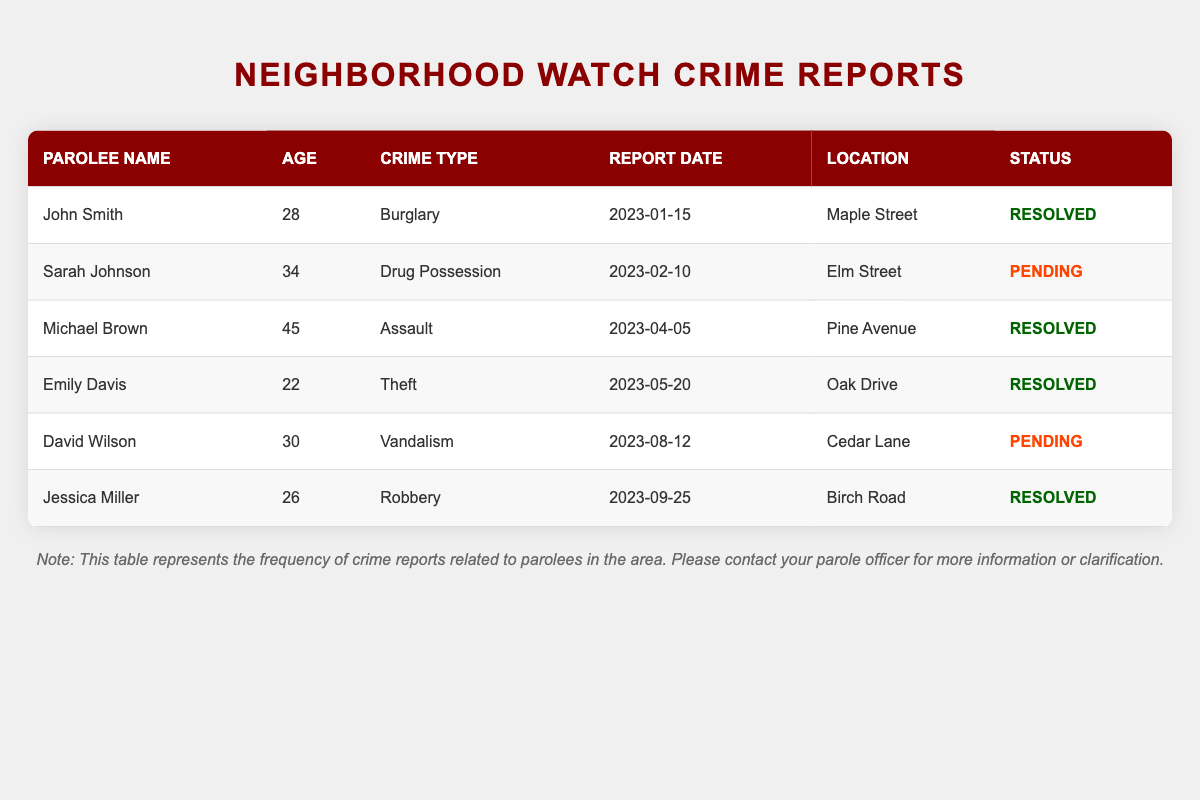What crime type was reported by Emily Davis? Emily Davis is listed in the table under the parolee name column, and her crime type is noted as Theft in the corresponding row.
Answer: Theft How many crime reports have a status of Pending? By reviewing the status column in the table, there are two entries with "Pending" status: one for Sarah Johnson and one for David Wilson.
Answer: 2 What is the average age of the parolees in the table? The ages of the parolees are 28, 34, 45, 22, 30, and 26. To find the average, sum these ages: 28 + 34 + 45 + 22 + 30 + 26 = 185. There are 6 parolees, so divide the total by 6: 185 / 6 = approximately 30.83.
Answer: 30.83 Is it true that no crime reports have been resolved for drug possession? In the table, Sarah Johnson's crime report for Drug Possession has a status of Pending, and there are no entries showing it as resolved. Therefore, it is true that no crime reports for this type have been resolved.
Answer: Yes Which location had the highest crime report in the table? To determine the highest crime report location, observe the report location column. Each location is listed only once. Thus, each location's crime count is equal, making it not applicable to define a single 'highest' location.
Answer: Not applicable How many resolved crime reports were made by individuals aged 30 or older? From the table, we look at the resolved crime reports: John Smith (28), Michael Brown (45), Emily Davis (22), and Jessica Miller (26). Only Michael Brown (age 45) falls into the 30 or older category and is marked as resolved. Hence, the answer is one.
Answer: 1 What types of crimes have been reported in total? The table lists various types of crimes: Burglary, Drug Possession, Assault, Theft, Vandalism, and Robbery. Count these unique entries to find there are a total of six different crime types reported.
Answer: 6 How many parolees are involved in crimes with a status of Resolved? By examining the status column, we find three entries marked as Resolved: John Smith, Michael Brown, and Jessica Miller.
Answer: 3 Which parolee had the latest report date? The report dates are as follows: January 15, February 10, April 5, May 20, August 12, and September 25. By comparing these, the latest date is September 25, corresponding to the entry for Jessica Miller.
Answer: Jessica Miller 